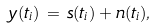Convert formula to latex. <formula><loc_0><loc_0><loc_500><loc_500>y ( t _ { i } ) \, = \, s ( t _ { i } ) + n ( t _ { i } ) ,</formula> 